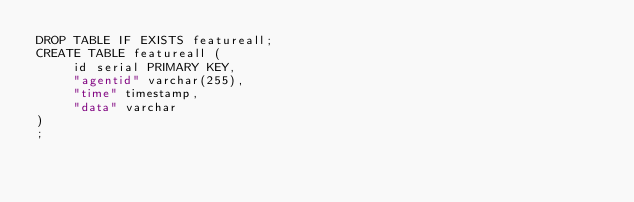<code> <loc_0><loc_0><loc_500><loc_500><_SQL_>DROP TABLE IF EXISTS featureall;
CREATE TABLE featureall (
     id serial PRIMARY KEY,
     "agentid" varchar(255),
     "time" timestamp,
     "data" varchar
)
;</code> 